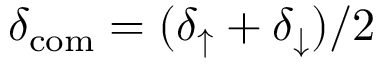<formula> <loc_0><loc_0><loc_500><loc_500>\delta _ { c o m } = ( \delta _ { \uparrow } + \delta _ { \downarrow } ) / 2</formula> 